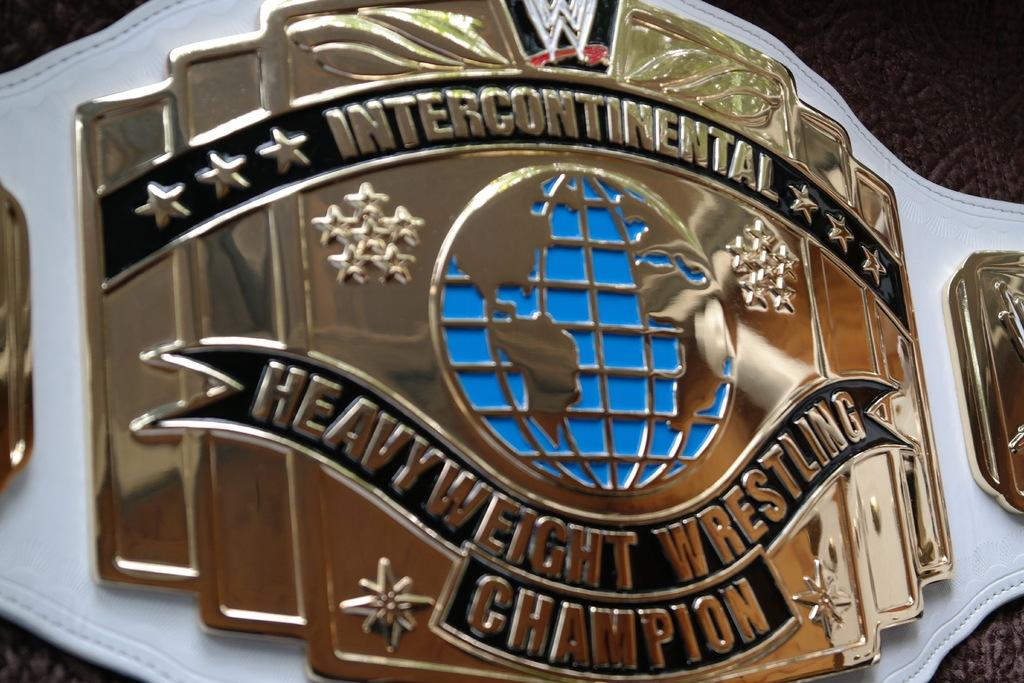What is the main object in the image? There is a championship belt in the image. What can be seen on the surface of the belt? The belt has logos on it. Are there any words or phrases on the belt? Yes, the belt has text on it. What type of chin is visible on the belt in the image? There is no chin present on the belt in the image. Is there a hose attached to the belt in the image? There is no hose present on the belt in the image. 